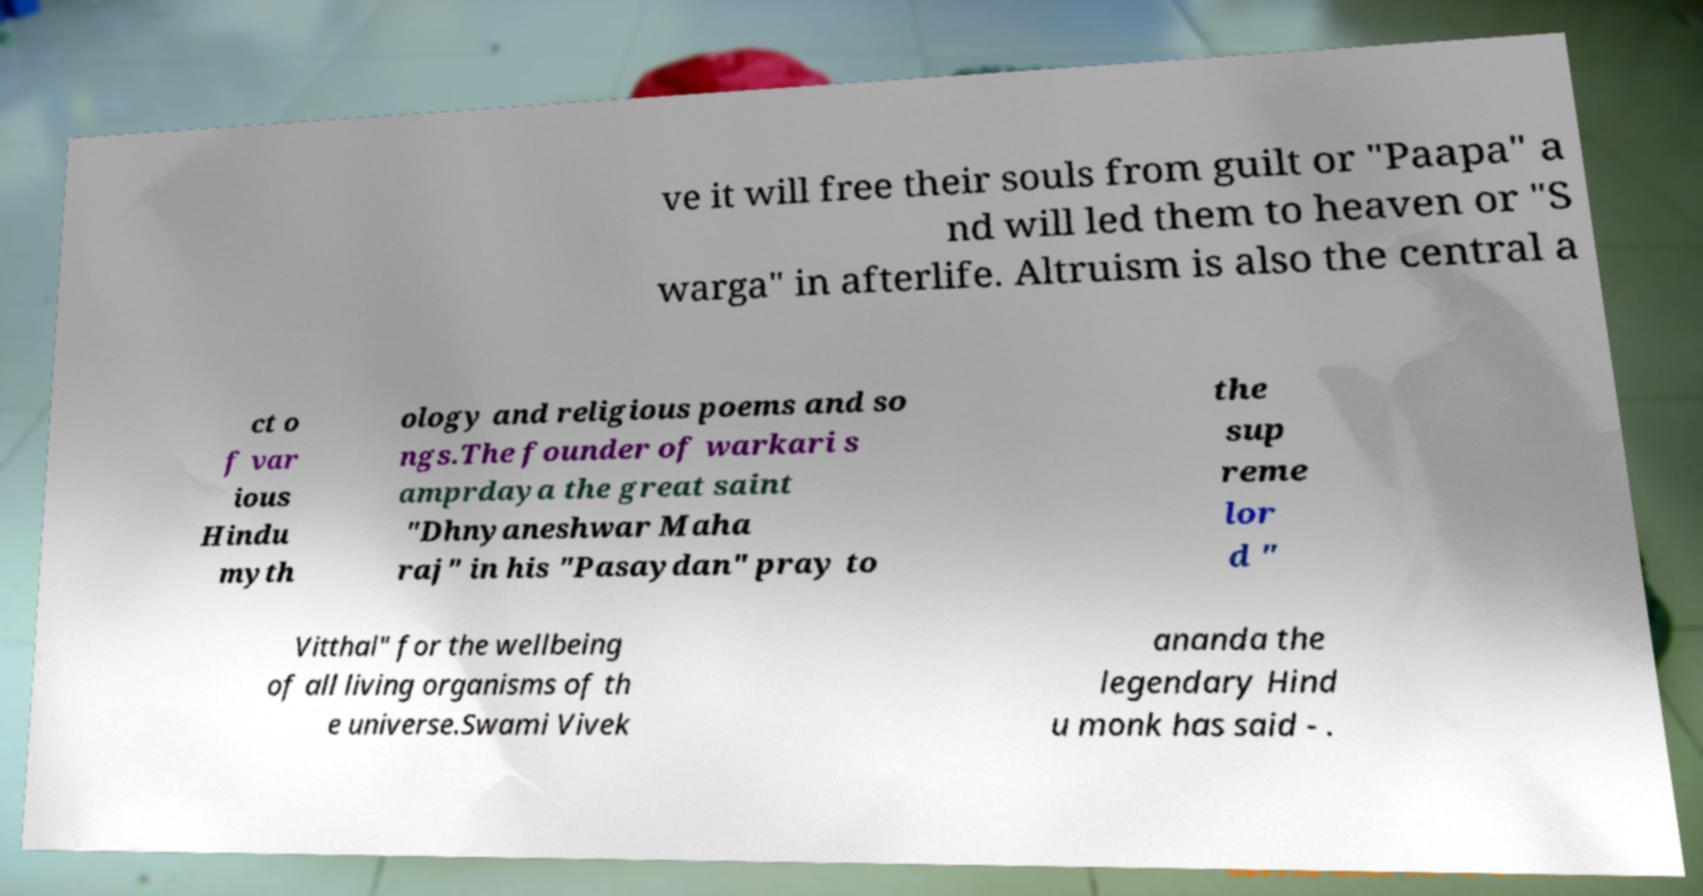Could you assist in decoding the text presented in this image and type it out clearly? ve it will free their souls from guilt or "Paapa" a nd will led them to heaven or "S warga" in afterlife. Altruism is also the central a ct o f var ious Hindu myth ology and religious poems and so ngs.The founder of warkari s amprdaya the great saint "Dhnyaneshwar Maha raj" in his "Pasaydan" pray to the sup reme lor d " Vitthal" for the wellbeing of all living organisms of th e universe.Swami Vivek ananda the legendary Hind u monk has said - . 